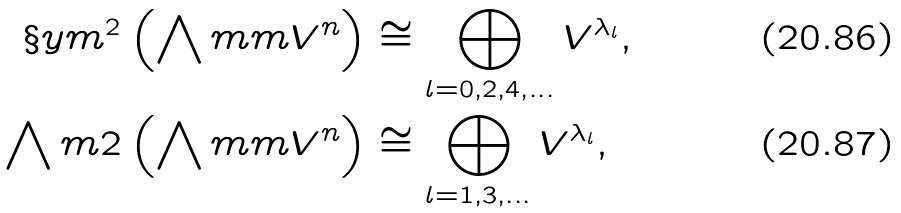Convert formula to latex. <formula><loc_0><loc_0><loc_500><loc_500>\S y m ^ { 2 } \left ( \bigwedge m { m } V ^ { n } \right ) & \cong \bigoplus _ { l = 0 , 2 , 4 , \dots } V ^ { \lambda _ { l } } , \\ \bigwedge m { 2 } \left ( \bigwedge m { m } V ^ { n } \right ) & \cong \bigoplus _ { l = 1 , 3 , \dots } V ^ { \lambda _ { l } } ,</formula> 